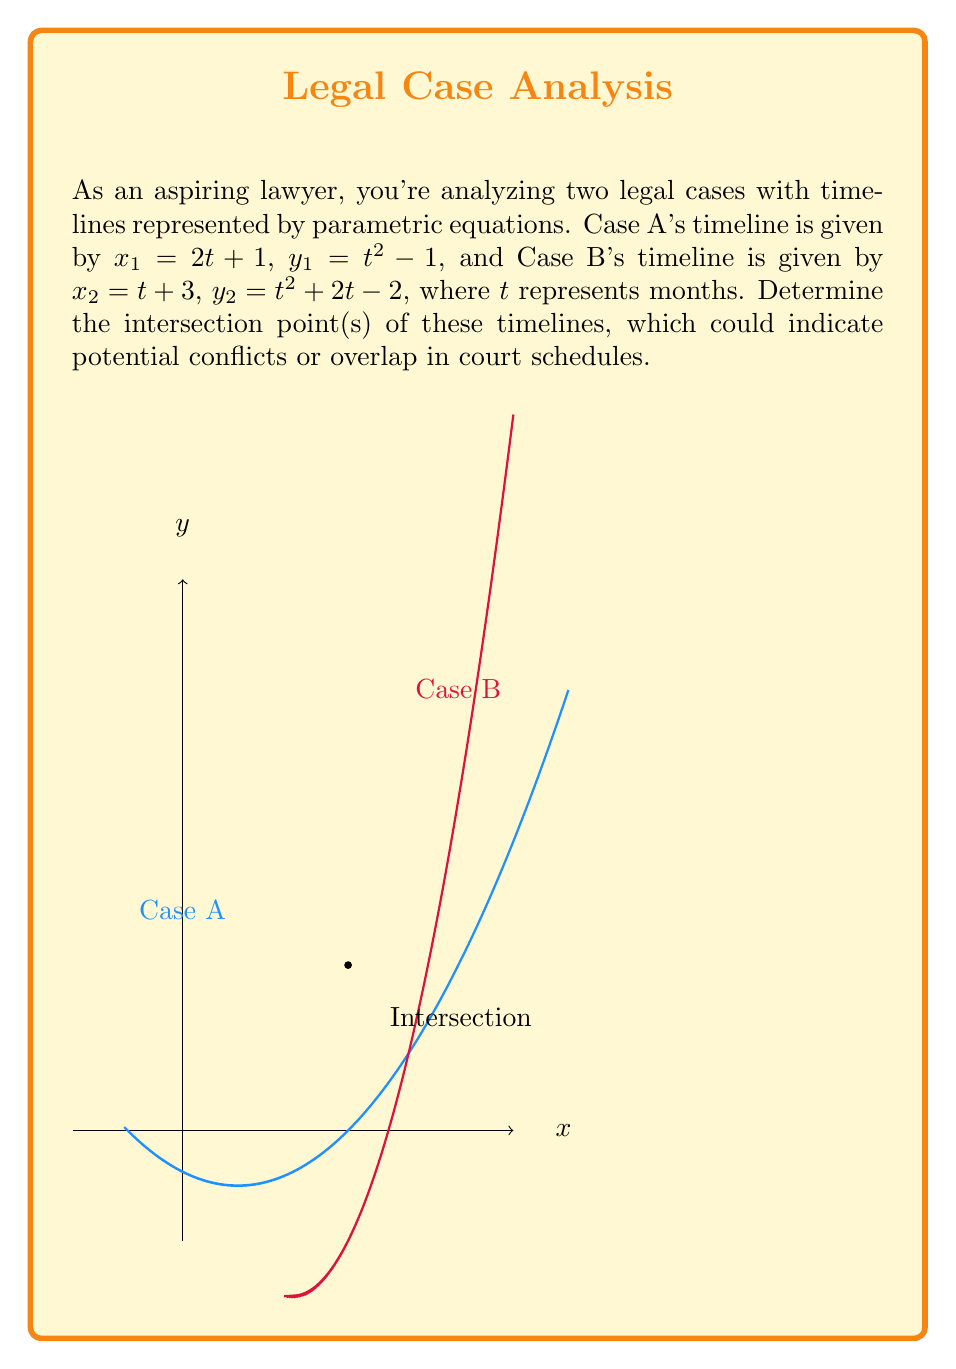Solve this math problem. To find the intersection points, we need to solve the system of equations:

1) Set $x_1 = x_2$:
   $2t + 1 = t + 3$
   $t = 2$

2) Substitute $t = 2$ into either $x$ equation to find the $x$-coordinate:
   $x = 2(2) + 1 = 5$

3) To find the $y$-coordinate, substitute $t = 2$ into either $y$ equation:
   $y_1 = 2^2 - 1 = 3$
   $y_2 = 2^2 + 2(2) - 2 = 4 + 4 - 2 = 6$

4) Since $y_1 \neq y_2$ when $t = 2$, we need to set $y_1 = y_2$ and solve:
   $t^2 - 1 = t^2 + 2t - 2$
   $0 = 2t - 1$
   $t = \frac{1}{2}$

5) Substitute $t = \frac{1}{2}$ into either $x$ equation:
   $x = 2(\frac{1}{2}) + 1 = 2$

6) Substitute $t = \frac{1}{2}$ into either $y$ equation:
   $y = (\frac{1}{2})^2 - 1 = \frac{1}{4} - 1 = -\frac{3}{4}$

Therefore, the intersection point is $(3, 3)$.
Answer: $(3, 3)$ 